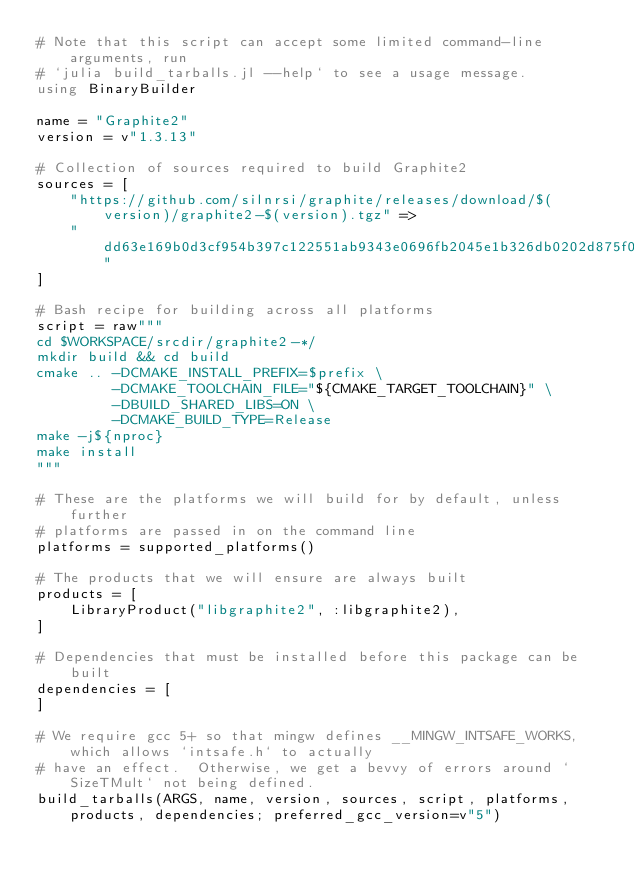<code> <loc_0><loc_0><loc_500><loc_500><_Julia_># Note that this script can accept some limited command-line arguments, run
# `julia build_tarballs.jl --help` to see a usage message.
using BinaryBuilder

name = "Graphite2"
version = v"1.3.13"

# Collection of sources required to build Graphite2
sources = [
    "https://github.com/silnrsi/graphite/releases/download/$(version)/graphite2-$(version).tgz" =>
    "dd63e169b0d3cf954b397c122551ab9343e0696fb2045e1b326db0202d875f06"
]

# Bash recipe for building across all platforms
script = raw"""
cd $WORKSPACE/srcdir/graphite2-*/
mkdir build && cd build
cmake .. -DCMAKE_INSTALL_PREFIX=$prefix \
         -DCMAKE_TOOLCHAIN_FILE="${CMAKE_TARGET_TOOLCHAIN}" \
         -DBUILD_SHARED_LIBS=ON \
         -DCMAKE_BUILD_TYPE=Release
make -j${nproc}
make install
"""

# These are the platforms we will build for by default, unless further
# platforms are passed in on the command line
platforms = supported_platforms()

# The products that we will ensure are always built
products = [
    LibraryProduct("libgraphite2", :libgraphite2),
]

# Dependencies that must be installed before this package can be built
dependencies = [
]

# We require gcc 5+ so that mingw defines __MINGW_INTSAFE_WORKS, which allows `intsafe.h` to actually
# have an effect.  Otherwise, we get a bevvy of errors around `SizeTMult` not being defined.
build_tarballs(ARGS, name, version, sources, script, platforms, products, dependencies; preferred_gcc_version=v"5")
</code> 